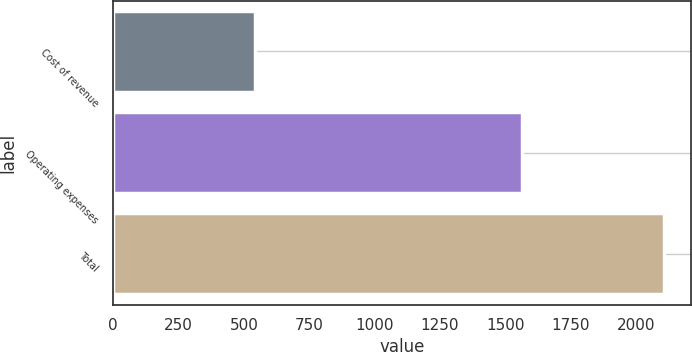Convert chart to OTSL. <chart><loc_0><loc_0><loc_500><loc_500><bar_chart><fcel>Cost of revenue<fcel>Operating expenses<fcel>Total<nl><fcel>543<fcel>1562.2<fcel>2105.2<nl></chart> 